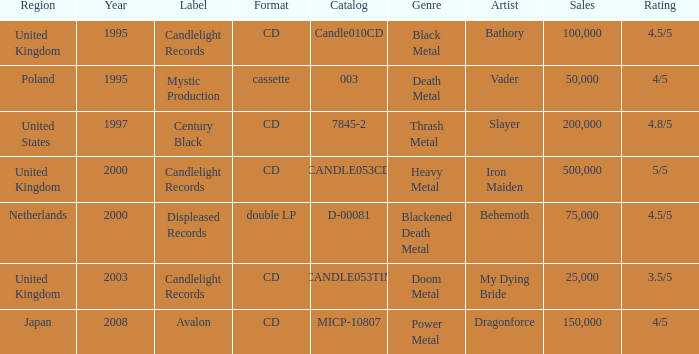What was the Candlelight Records Catalog of Candle053tin format? CD. 